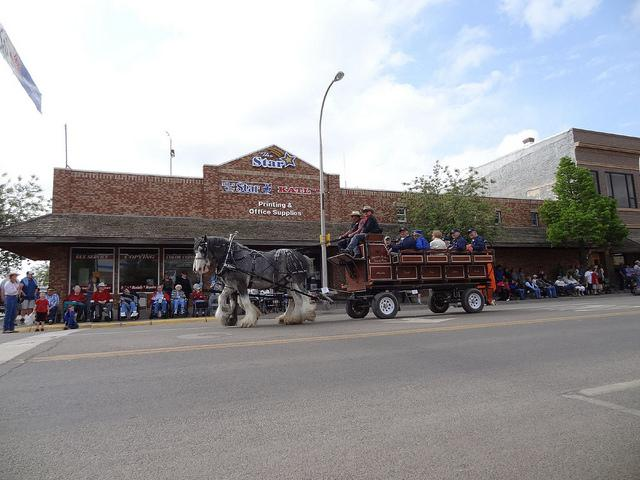What two factors are allowing the people to move?

Choices:
A) horse
B) driver
C) wheels
D) all correct all correct 